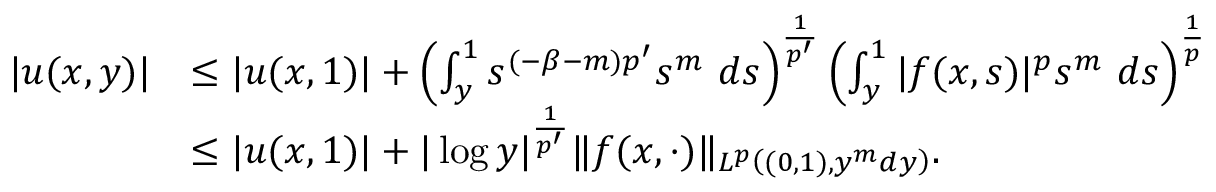<formula> <loc_0><loc_0><loc_500><loc_500>\begin{array} { r l } { | u ( x , y ) | } & { \leq | u ( x , 1 ) | + \left ( \int _ { y } ^ { 1 } s ^ { ( - \beta - m ) p ^ { \prime } } s ^ { m } \ d s \right ) ^ { \frac { 1 } { p ^ { \prime } } } \left ( \int _ { y } ^ { 1 } | f ( x , s ) | ^ { p } s ^ { m } \ d s \right ) ^ { \frac { 1 } { p } } } \\ & { \leq | u ( x , 1 ) | + | \log y | ^ { \frac { 1 } { p ^ { \prime } } } \| f ( x , \cdot ) \| _ { L ^ { p } \left ( ( 0 , 1 ) , y ^ { m } d y \right ) } . } \end{array}</formula> 